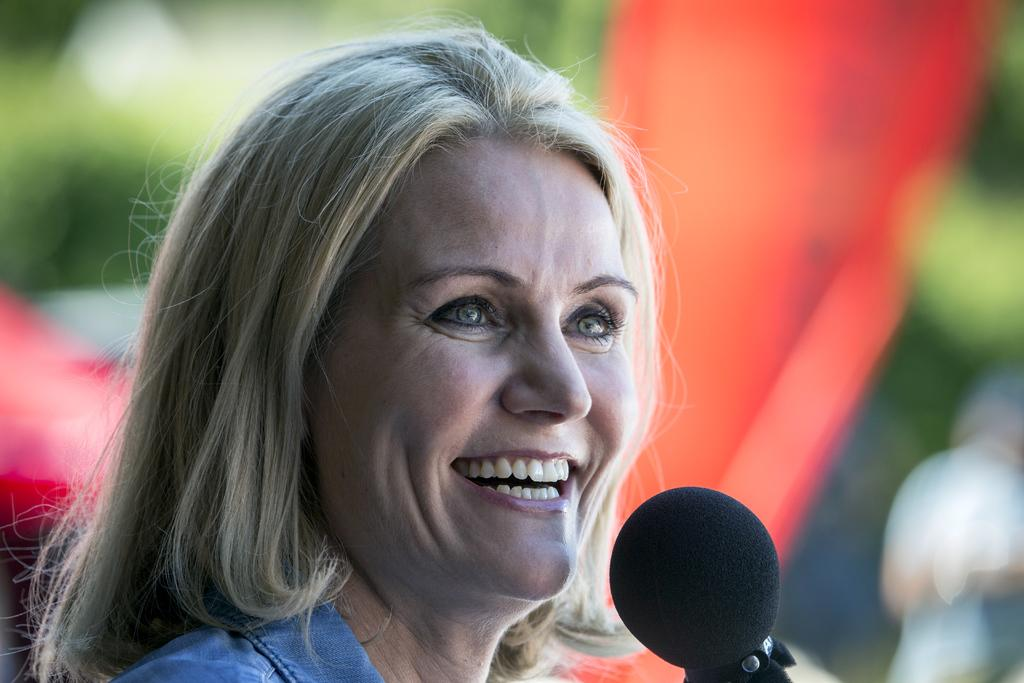Who is the main subject in the image? There is a lady in the image. What is the lady doing in the image? The lady is standing in the image. What is in front of the lady? There is a mic in front of the lady. What is the lady's facial expression? The lady is smiling in the image. What can be seen in the background of the image? There are trees in the background of the image. How would you describe the background of the image? The background is blurry in the image. How many cans are visible in the image? There are no cans present in the image. What type of feather can be seen on the lady's hat in the image? There is no feather on the lady's hat in the image. 